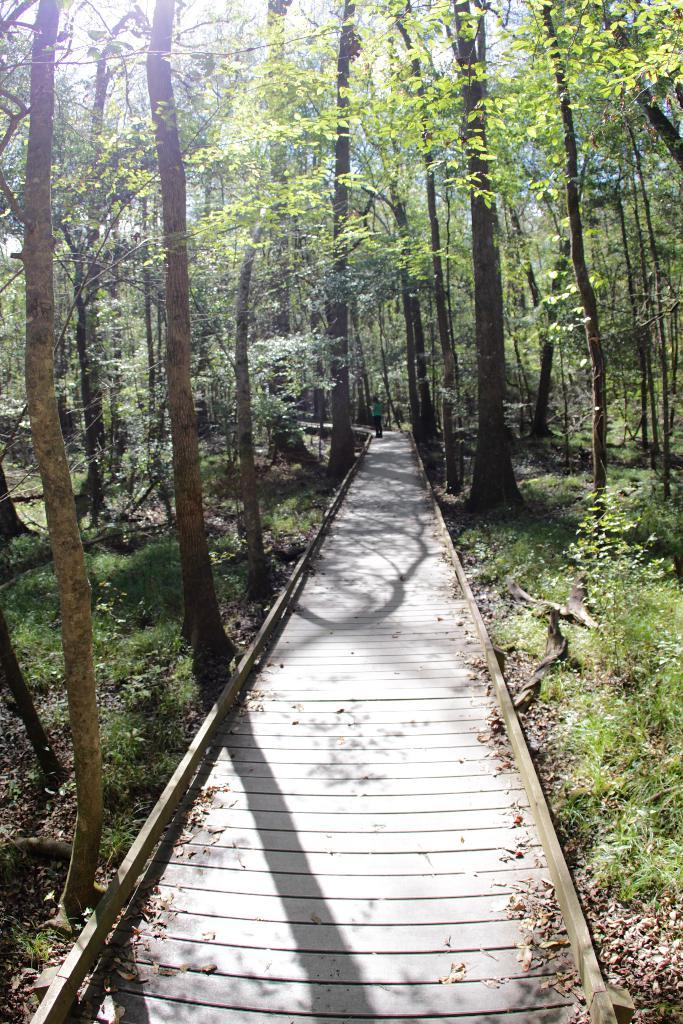What type of structure is located at the front of the image? There is a wooden platform in the image. Can you describe the surface near the platform? There is grass on the surface near the platform. What type of vegetation can be seen in the image? There are trees in the image. Where is the shelf located in the image? There is no shelf present in the image. What type of test is being conducted in the image? There is no test being conducted in the image. 